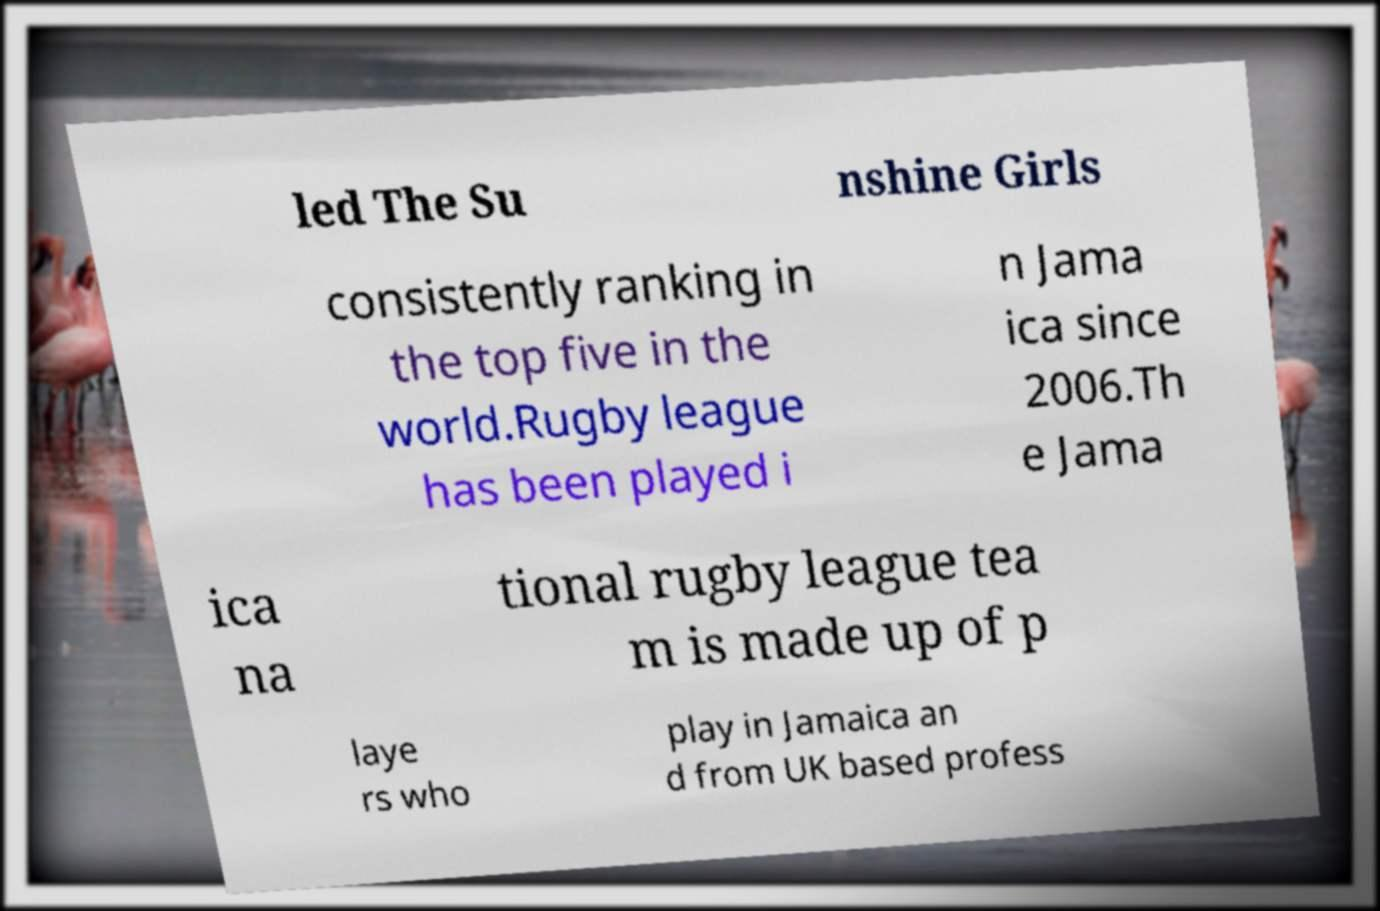Please read and relay the text visible in this image. What does it say? led The Su nshine Girls consistently ranking in the top five in the world.Rugby league has been played i n Jama ica since 2006.Th e Jama ica na tional rugby league tea m is made up of p laye rs who play in Jamaica an d from UK based profess 